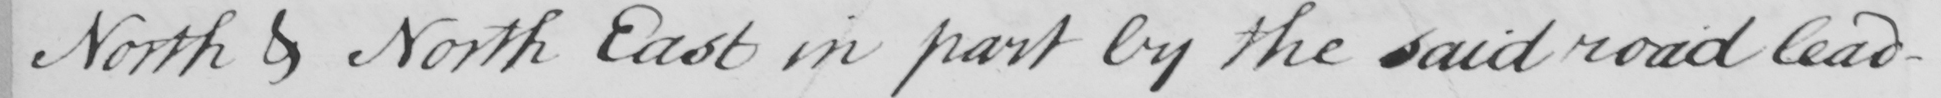What text is written in this handwritten line? North & North East in part by the said road lead- 